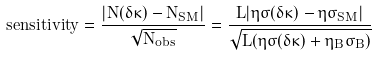Convert formula to latex. <formula><loc_0><loc_0><loc_500><loc_500>s e n s i t i v i t y = \frac { | N ( \delta \kappa ) - N _ { S M } | } { \sqrt { N _ { o b s } } } = \frac { L | \eta \sigma ( \delta \kappa ) - \eta \sigma _ { S M } | } { \sqrt { L ( \eta \sigma ( \delta \kappa ) + \eta _ { B } \sigma _ { B } ) } }</formula> 